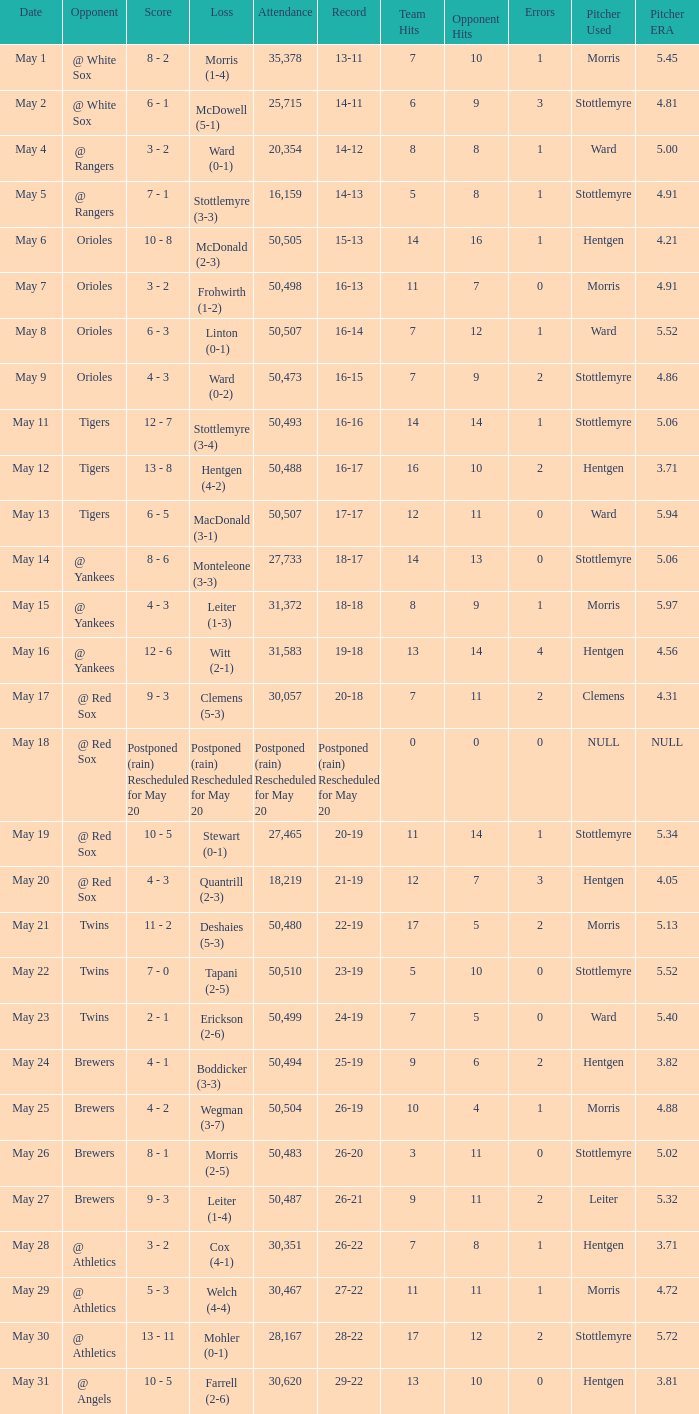On May 29 which team had the loss? Welch (4-4). 